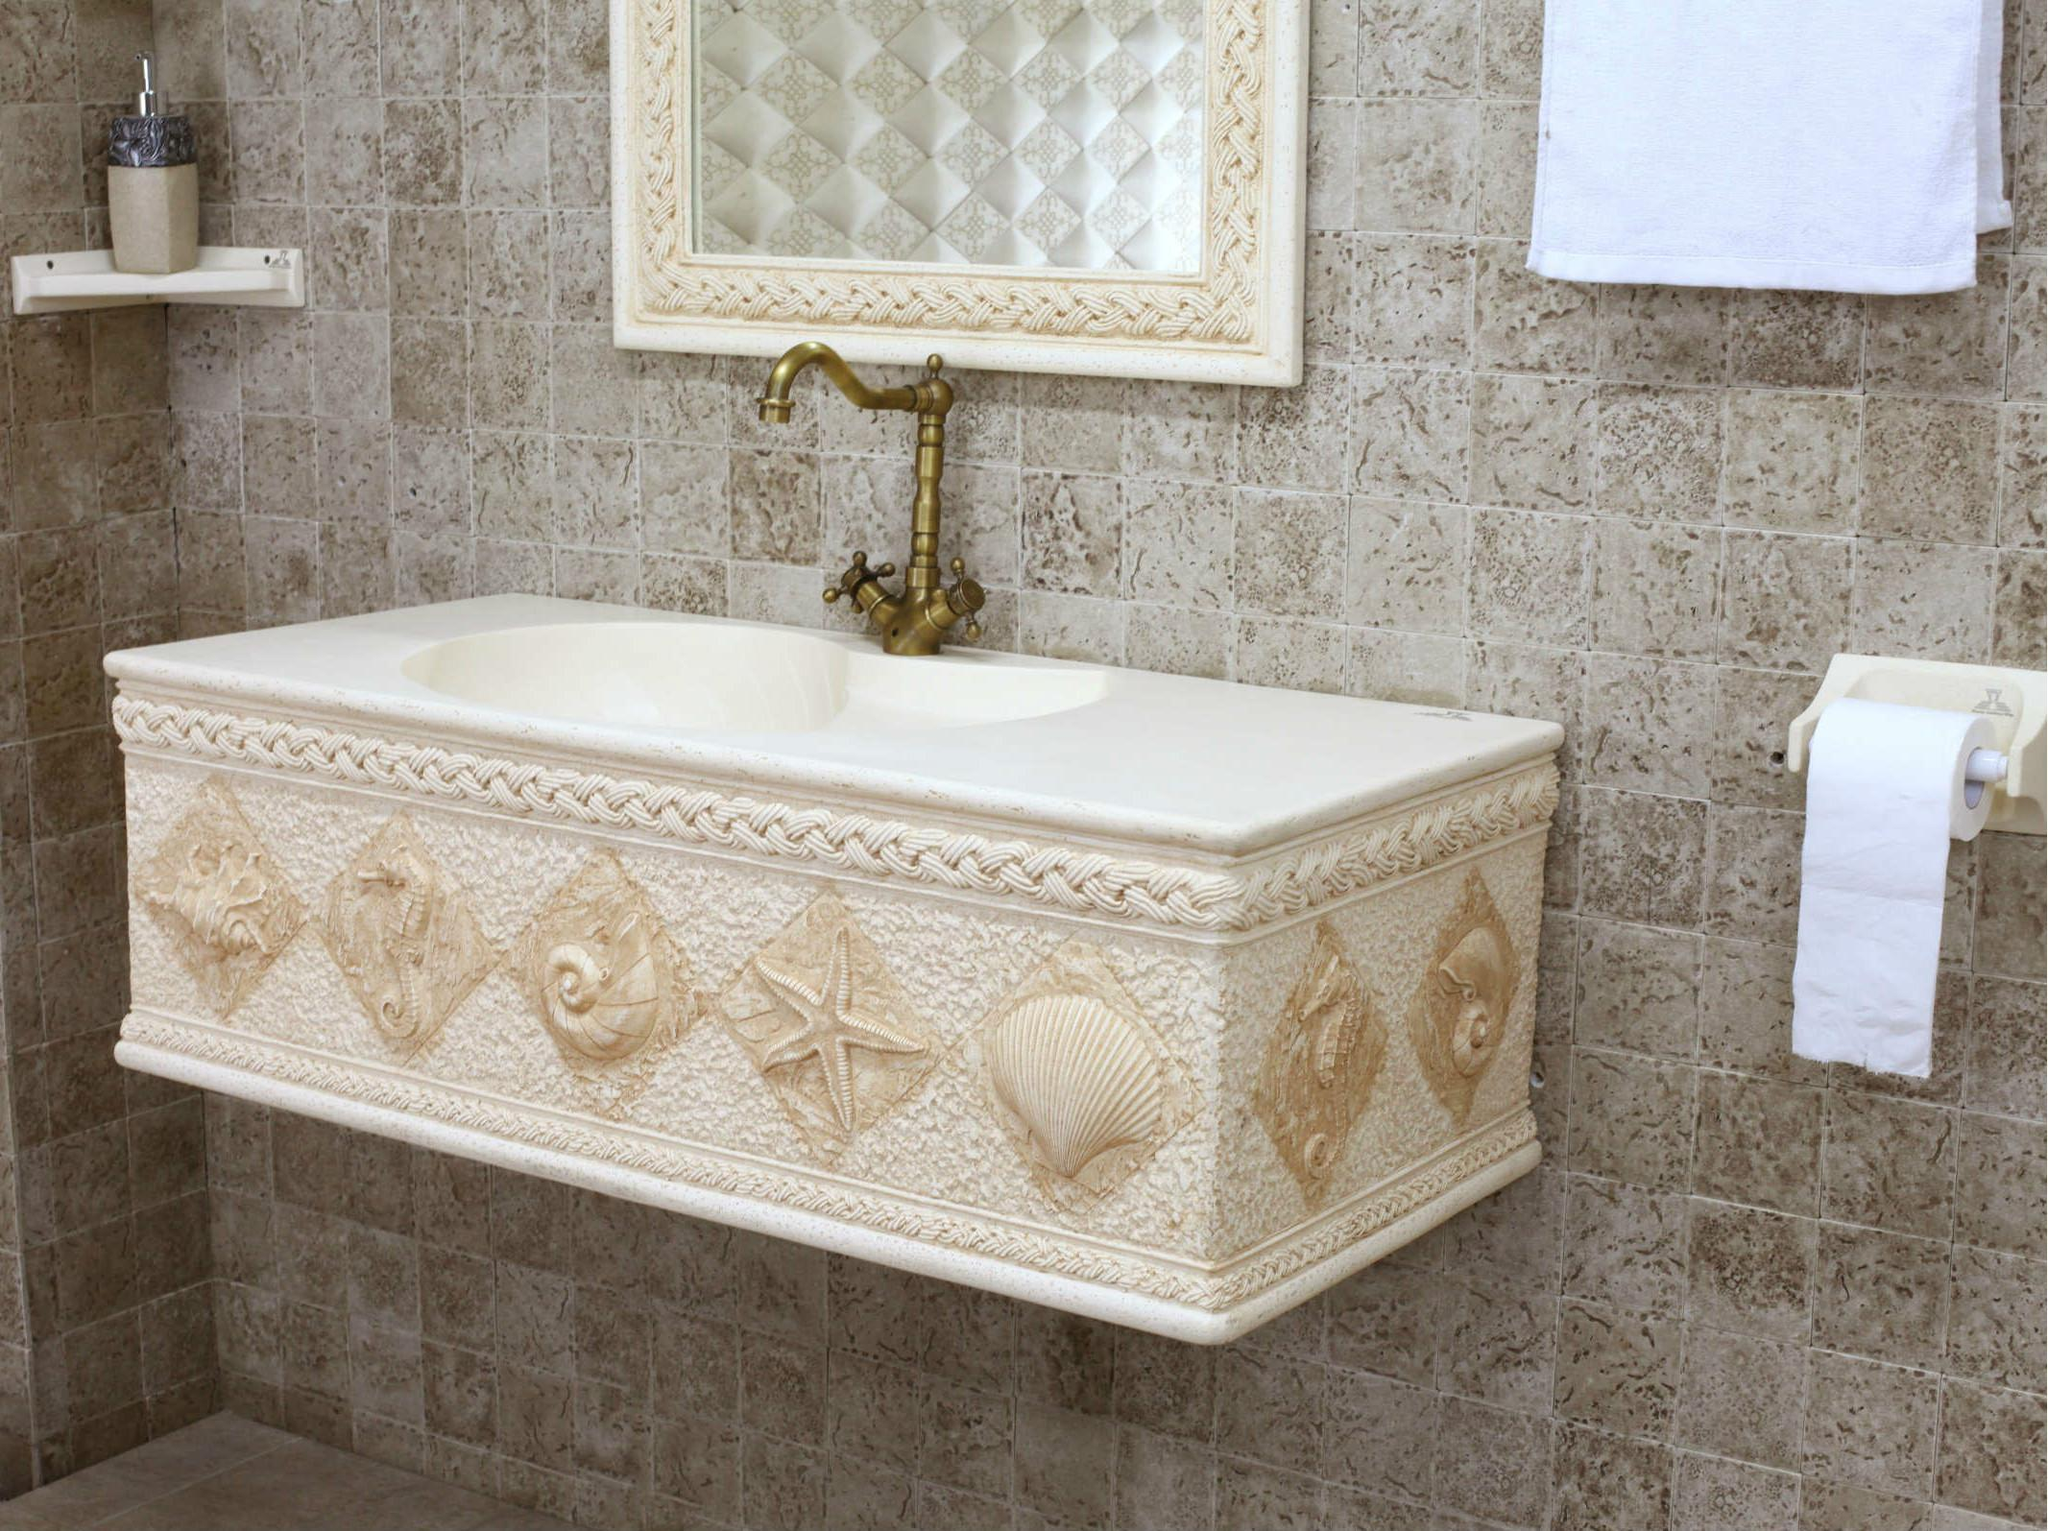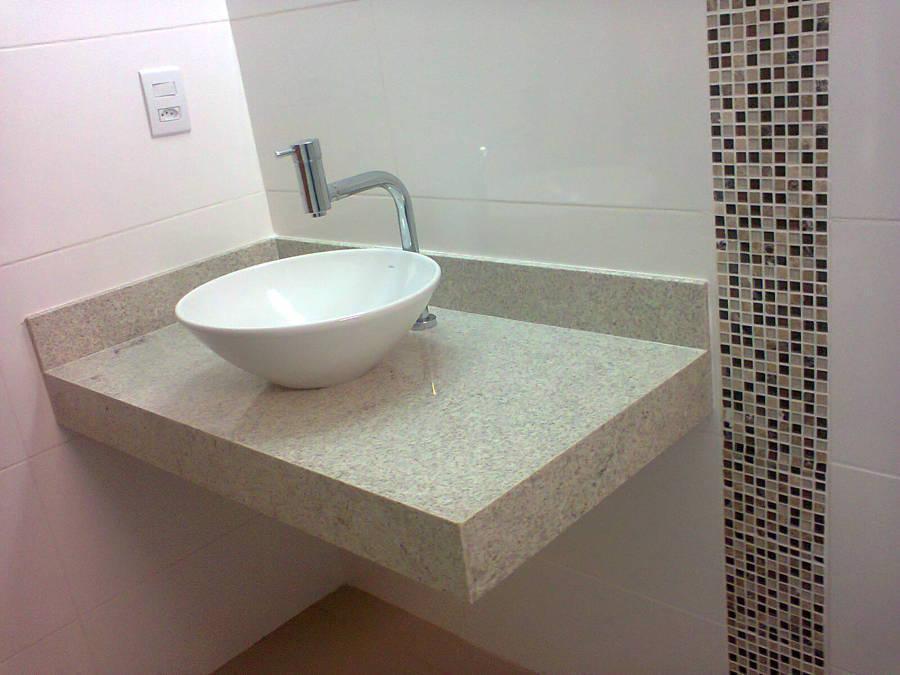The first image is the image on the left, the second image is the image on the right. Analyze the images presented: Is the assertion "Both images in the pair show sinks and one of them is seashell themed." valid? Answer yes or no. Yes. The first image is the image on the left, the second image is the image on the right. For the images displayed, is the sentence "The sink in the right image is a bowl sitting on a counter." factually correct? Answer yes or no. Yes. 